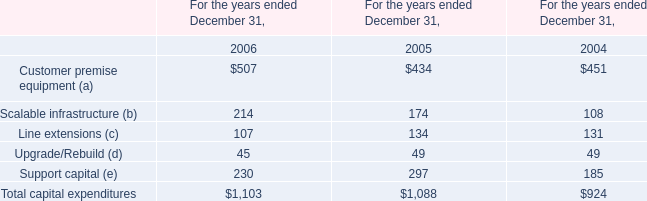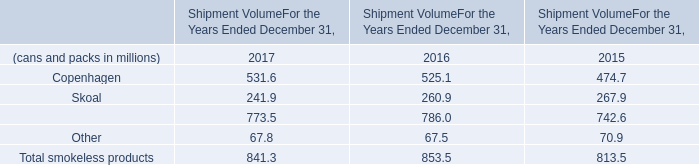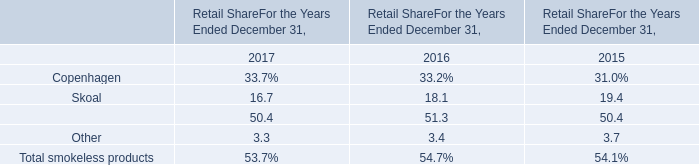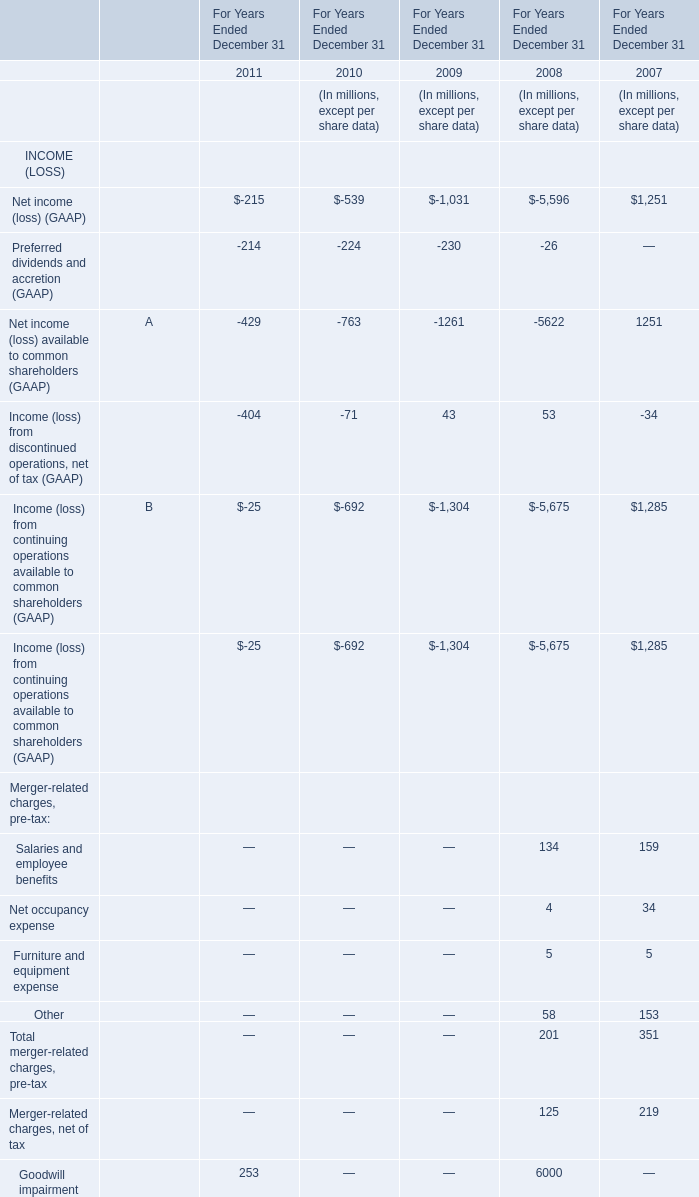What is the sum of Salaries and employee benefits in 2008 and Line extensions (c) in 2004? (in million) 
Computations: (134 + 131)
Answer: 265.0. 